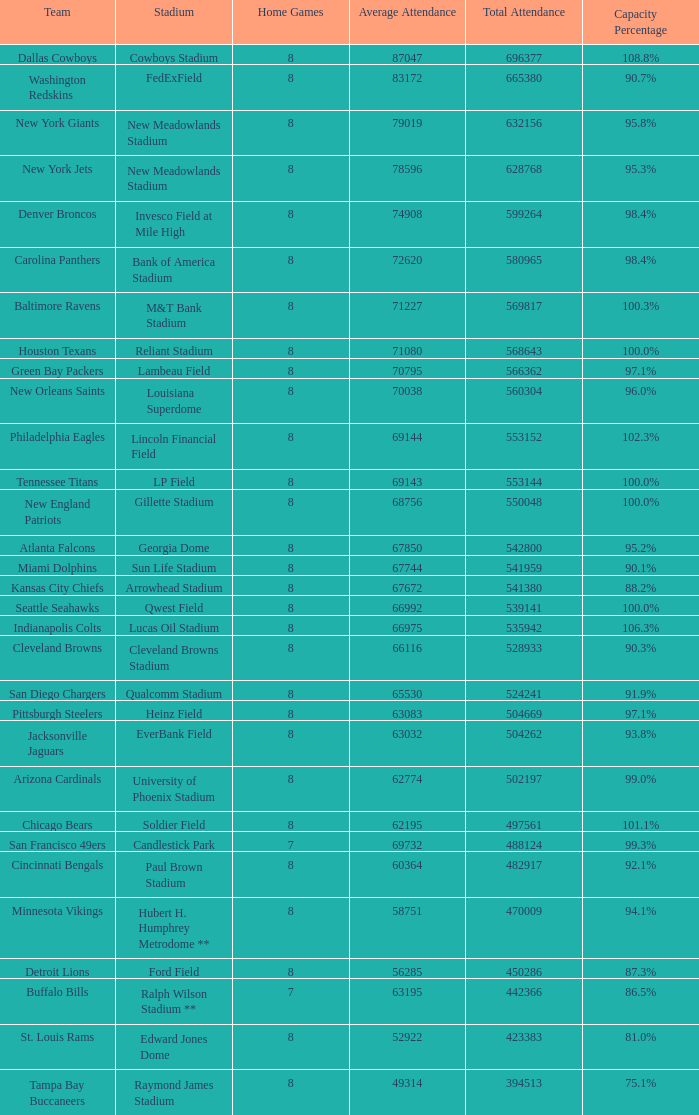What was the limit for the denver broncos? 98.4%. 